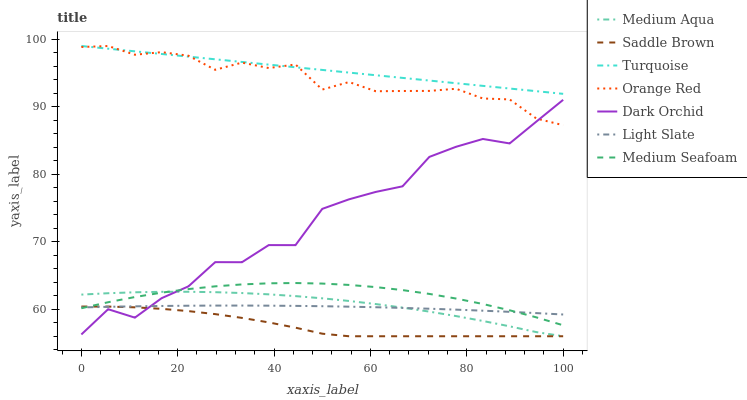Does Saddle Brown have the minimum area under the curve?
Answer yes or no. Yes. Does Turquoise have the maximum area under the curve?
Answer yes or no. Yes. Does Light Slate have the minimum area under the curve?
Answer yes or no. No. Does Light Slate have the maximum area under the curve?
Answer yes or no. No. Is Turquoise the smoothest?
Answer yes or no. Yes. Is Dark Orchid the roughest?
Answer yes or no. Yes. Is Light Slate the smoothest?
Answer yes or no. No. Is Light Slate the roughest?
Answer yes or no. No. Does Medium Aqua have the lowest value?
Answer yes or no. Yes. Does Light Slate have the lowest value?
Answer yes or no. No. Does Orange Red have the highest value?
Answer yes or no. Yes. Does Light Slate have the highest value?
Answer yes or no. No. Is Light Slate less than Turquoise?
Answer yes or no. Yes. Is Turquoise greater than Saddle Brown?
Answer yes or no. Yes. Does Light Slate intersect Dark Orchid?
Answer yes or no. Yes. Is Light Slate less than Dark Orchid?
Answer yes or no. No. Is Light Slate greater than Dark Orchid?
Answer yes or no. No. Does Light Slate intersect Turquoise?
Answer yes or no. No. 